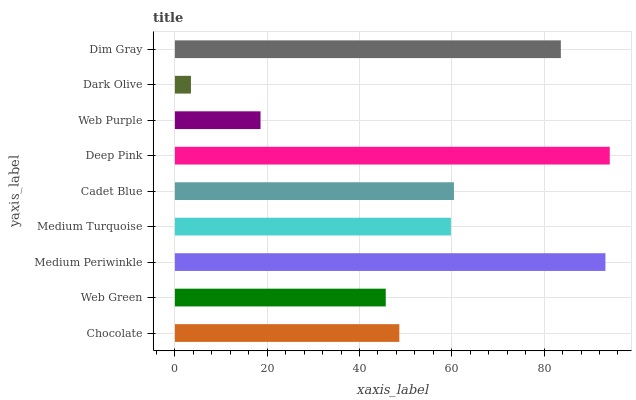Is Dark Olive the minimum?
Answer yes or no. Yes. Is Deep Pink the maximum?
Answer yes or no. Yes. Is Web Green the minimum?
Answer yes or no. No. Is Web Green the maximum?
Answer yes or no. No. Is Chocolate greater than Web Green?
Answer yes or no. Yes. Is Web Green less than Chocolate?
Answer yes or no. Yes. Is Web Green greater than Chocolate?
Answer yes or no. No. Is Chocolate less than Web Green?
Answer yes or no. No. Is Medium Turquoise the high median?
Answer yes or no. Yes. Is Medium Turquoise the low median?
Answer yes or no. Yes. Is Dark Olive the high median?
Answer yes or no. No. Is Dim Gray the low median?
Answer yes or no. No. 